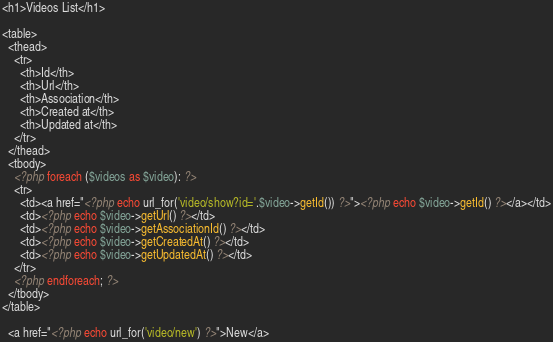<code> <loc_0><loc_0><loc_500><loc_500><_PHP_><h1>Videos List</h1>

<table>
  <thead>
    <tr>
      <th>Id</th>
      <th>Url</th>
      <th>Association</th>
      <th>Created at</th>
      <th>Updated at</th>
    </tr>
  </thead>
  <tbody>
    <?php foreach ($videos as $video): ?>
    <tr>
      <td><a href="<?php echo url_for('video/show?id='.$video->getId()) ?>"><?php echo $video->getId() ?></a></td>
      <td><?php echo $video->getUrl() ?></td>
      <td><?php echo $video->getAssociationId() ?></td>
      <td><?php echo $video->getCreatedAt() ?></td>
      <td><?php echo $video->getUpdatedAt() ?></td>
    </tr>
    <?php endforeach; ?>
  </tbody>
</table>

  <a href="<?php echo url_for('video/new') ?>">New</a>
</code> 